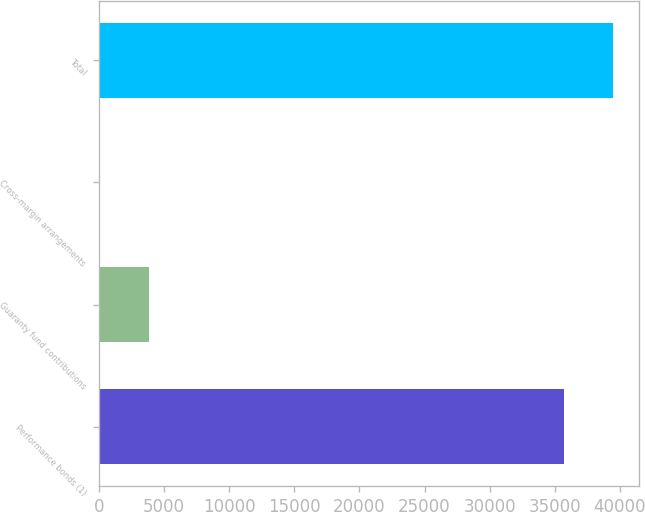Convert chart to OTSL. <chart><loc_0><loc_0><loc_500><loc_500><bar_chart><fcel>Performance bonds (1)<fcel>Guaranty fund contributions<fcel>Cross-margin arrangements<fcel>Total<nl><fcel>35726.5<fcel>3851.46<fcel>107.9<fcel>39470.1<nl></chart> 